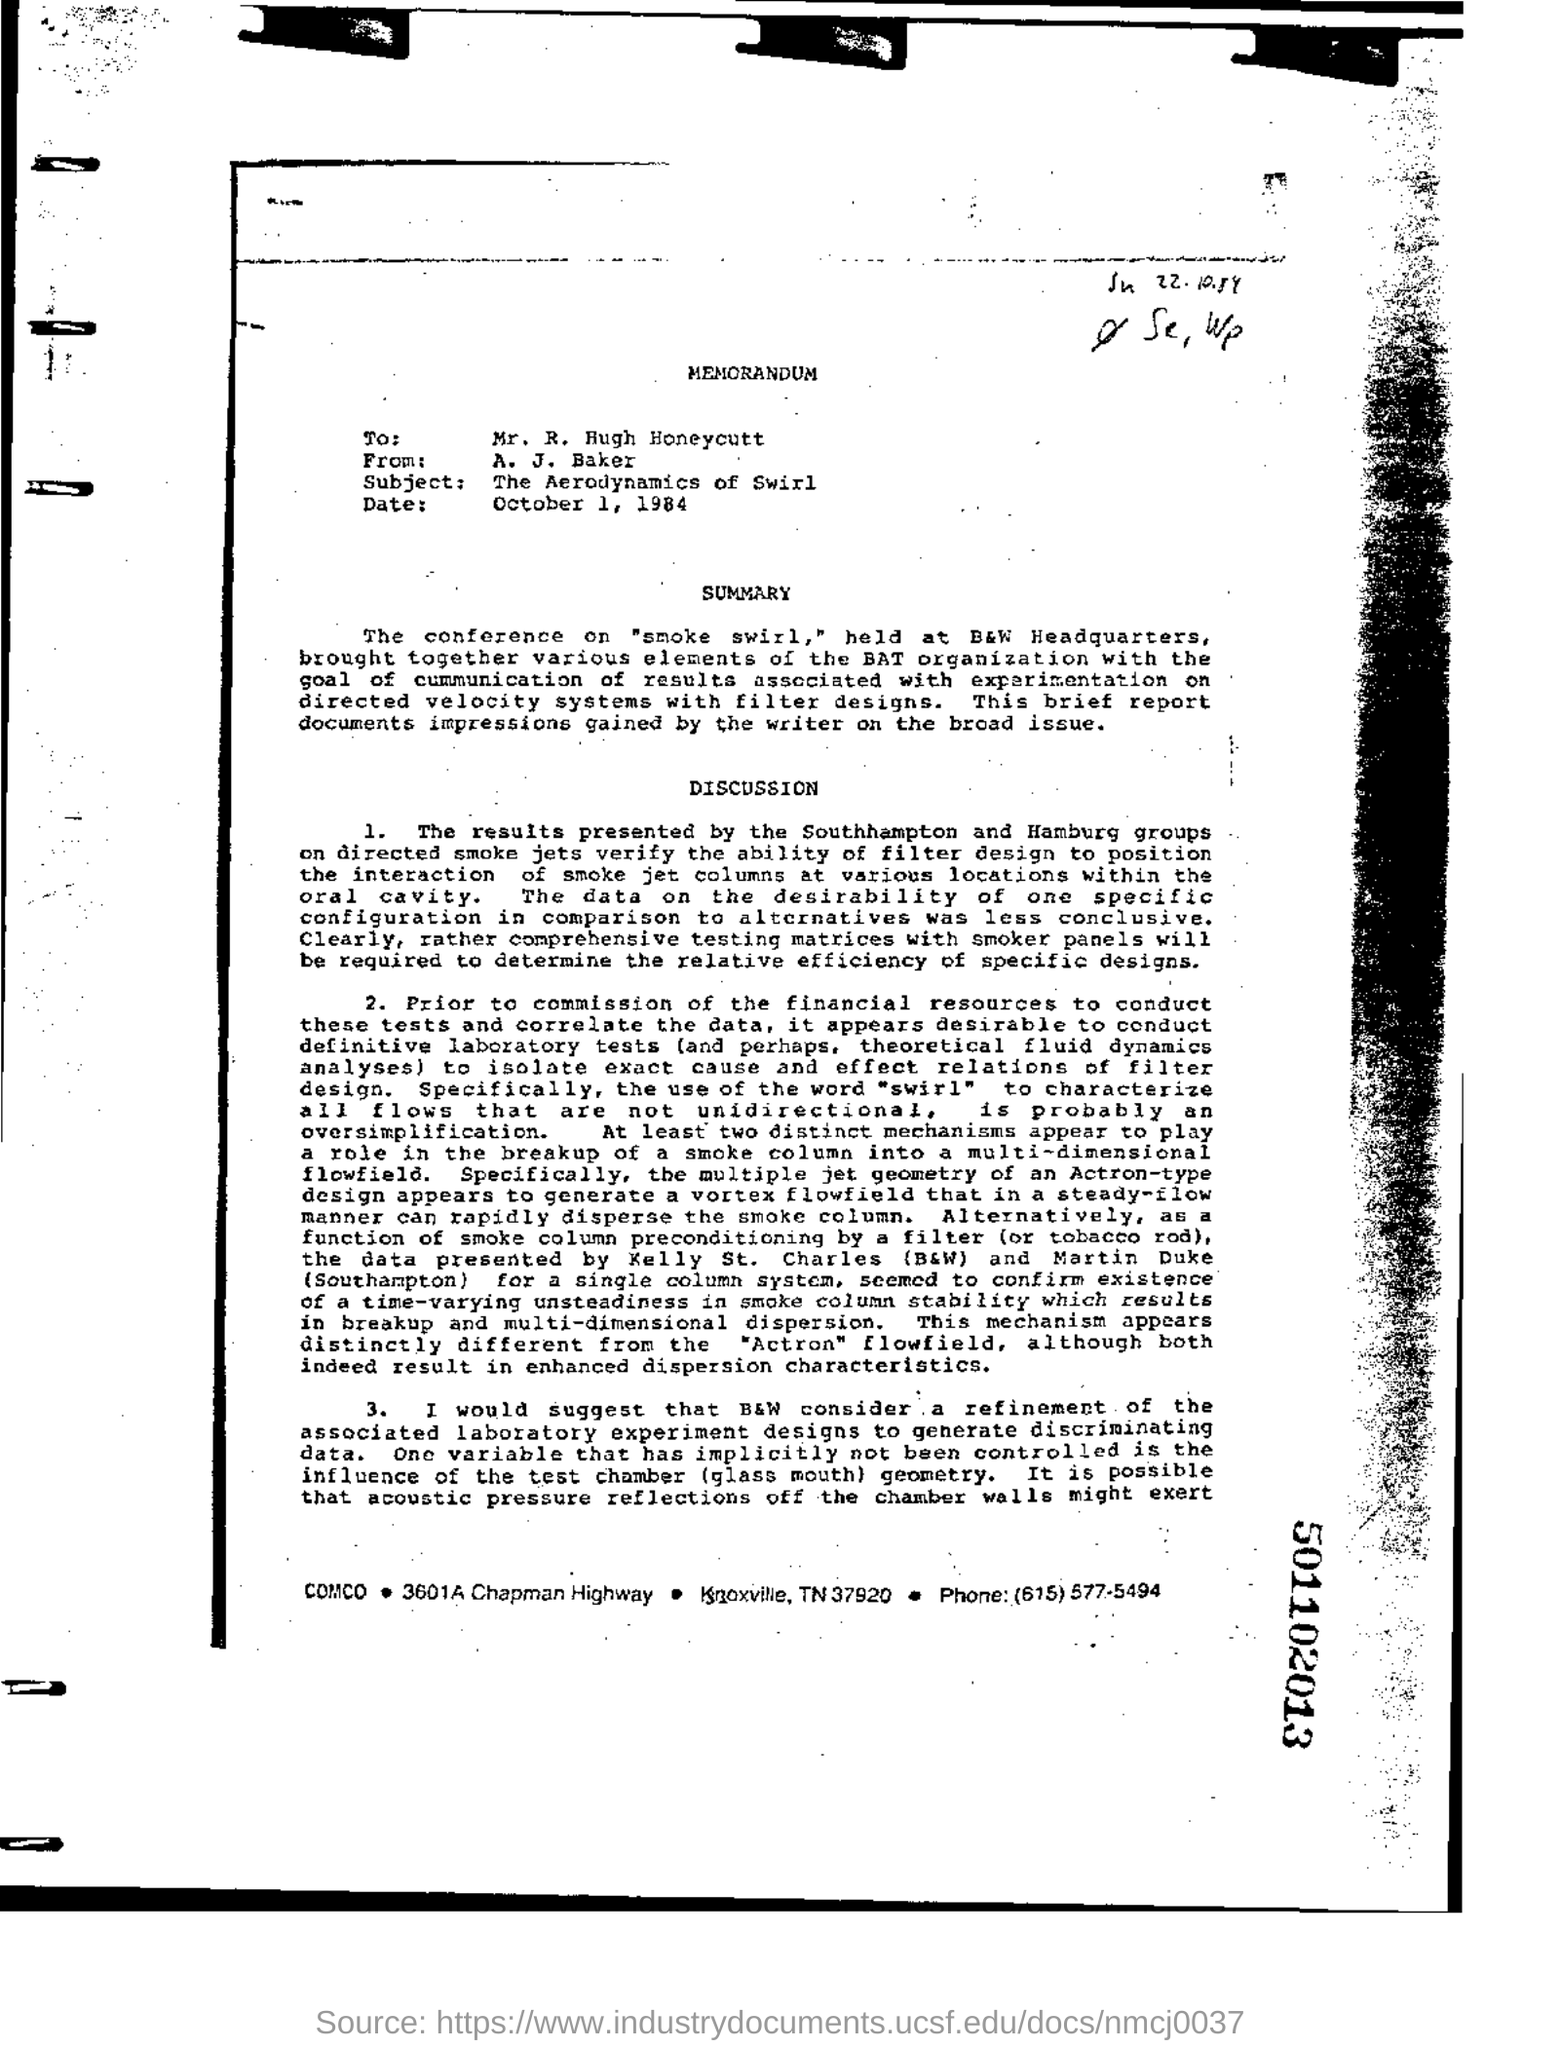Heading of the document?
Provide a short and direct response. MEMORANDUM. Where was the conference held?
Offer a very short reply. B&W Headquarters. How many distinct mechanisms appear to play a role in the breakup of a smoke column into a multi-dimensional flowfield?
Your response must be concise. Two. One variable that has implicitly not been controlled?
Your response must be concise. The influence of the test chamber (glass mouth) geometry. 